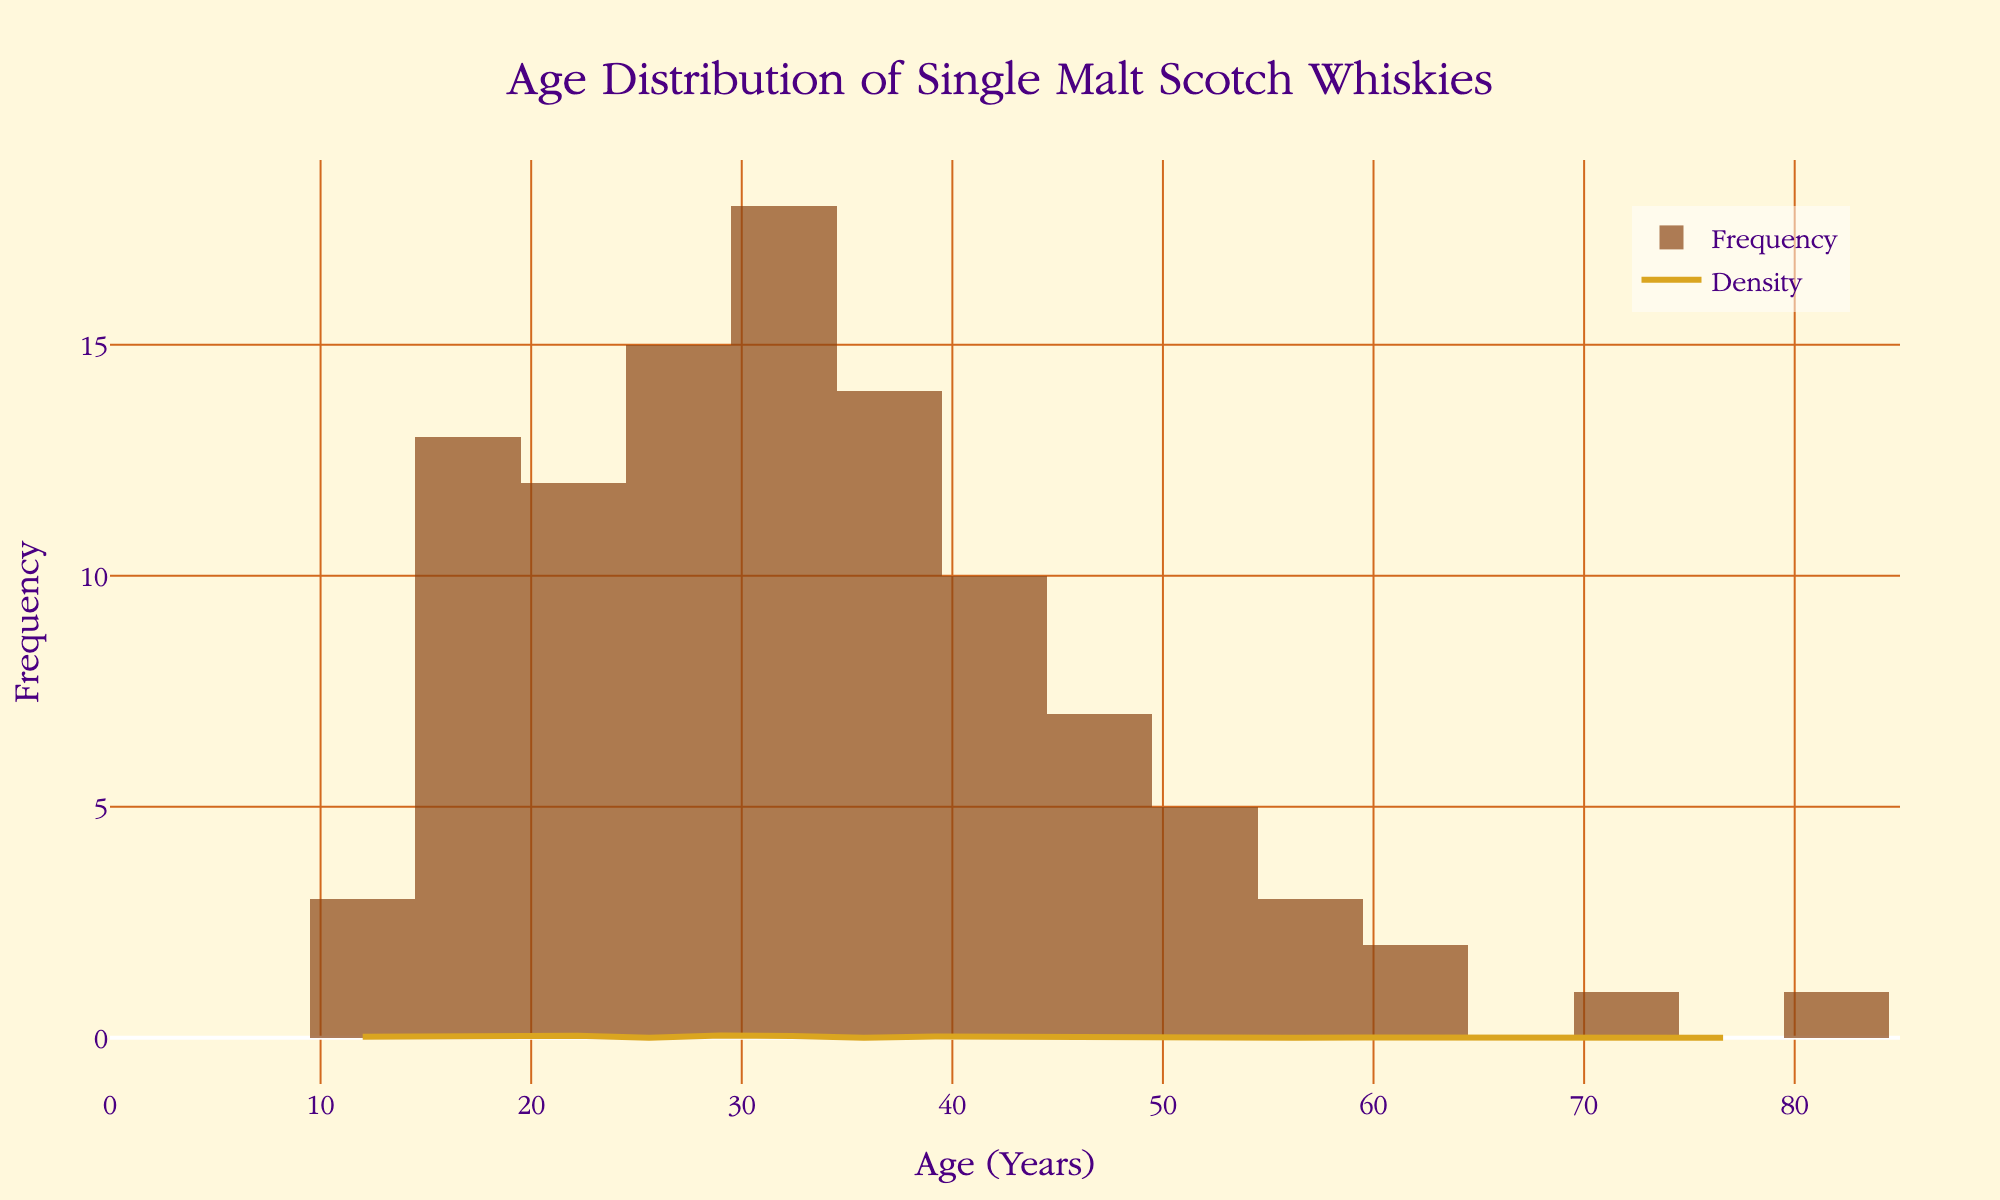What is the main title of the plot? The main title is typically positioned at the top center of the figure. It provides an overall summary of what the plot represents. In this case, it is visually prominent and helps viewers immediately understand the context.
Answer: Age Distribution of Single Malt Scotch Whiskies What is the age with the highest frequency? To find the age with the highest frequency, look for the tallest bar in the histogram. The height of each bar corresponds to the frequency of whiskies at that specific age.
Answer: 30 What is the general trend of the density curve from age 12 to age 80? Observing the density curve, which provides a smoothed estimation of the frequency distribution, it starts low, peaks around age 30, gradually declines, and reaches relatively low values again beyond age 50.
Answer: It peaks at age 30 and then declines Is there a higher frequency of whiskies aged less than 25 years or more than 25 years? Sum the frequencies of whiskies aged less than 25 years and compare it to the sum of frequencies of whiskies aged more than 25 years. For ages < 25: (3+5+8+12+15) = 43. For ages > 25: (18+14+10+7+5+3+2+1+1) = 61.
Answer: More than 25 years How many data points represent whiskies aged 50 years and older? Count the individual frequencies associated with the ages 50 years and older. For ages ≥ 50: 5 (50) + 3 (55) + 2 (60) + 1 (70) + 1 (80) = 12.
Answer: 12 Which age range appears to have the most significant change in density? The density curve shows how the frequency distribution changes. The most significant change is typically observed where the curve rises rapidly to its peak or declines steeply. The peak around age 30 suggests a fast-rising and rapid decline shortly after.
Answer: Around age 30 What is the frequency of the oldest whisky in the collection? Look for the frequency value associated with the oldest age displayed in the histogram, which is 80 years in this case.
Answer: 1 